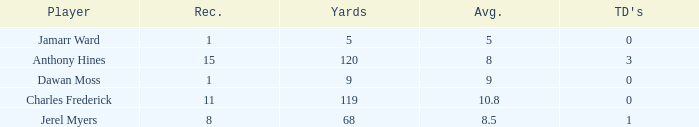What is the total Avg when TDs are 0 and Dawan Moss is a player? 0.0. 